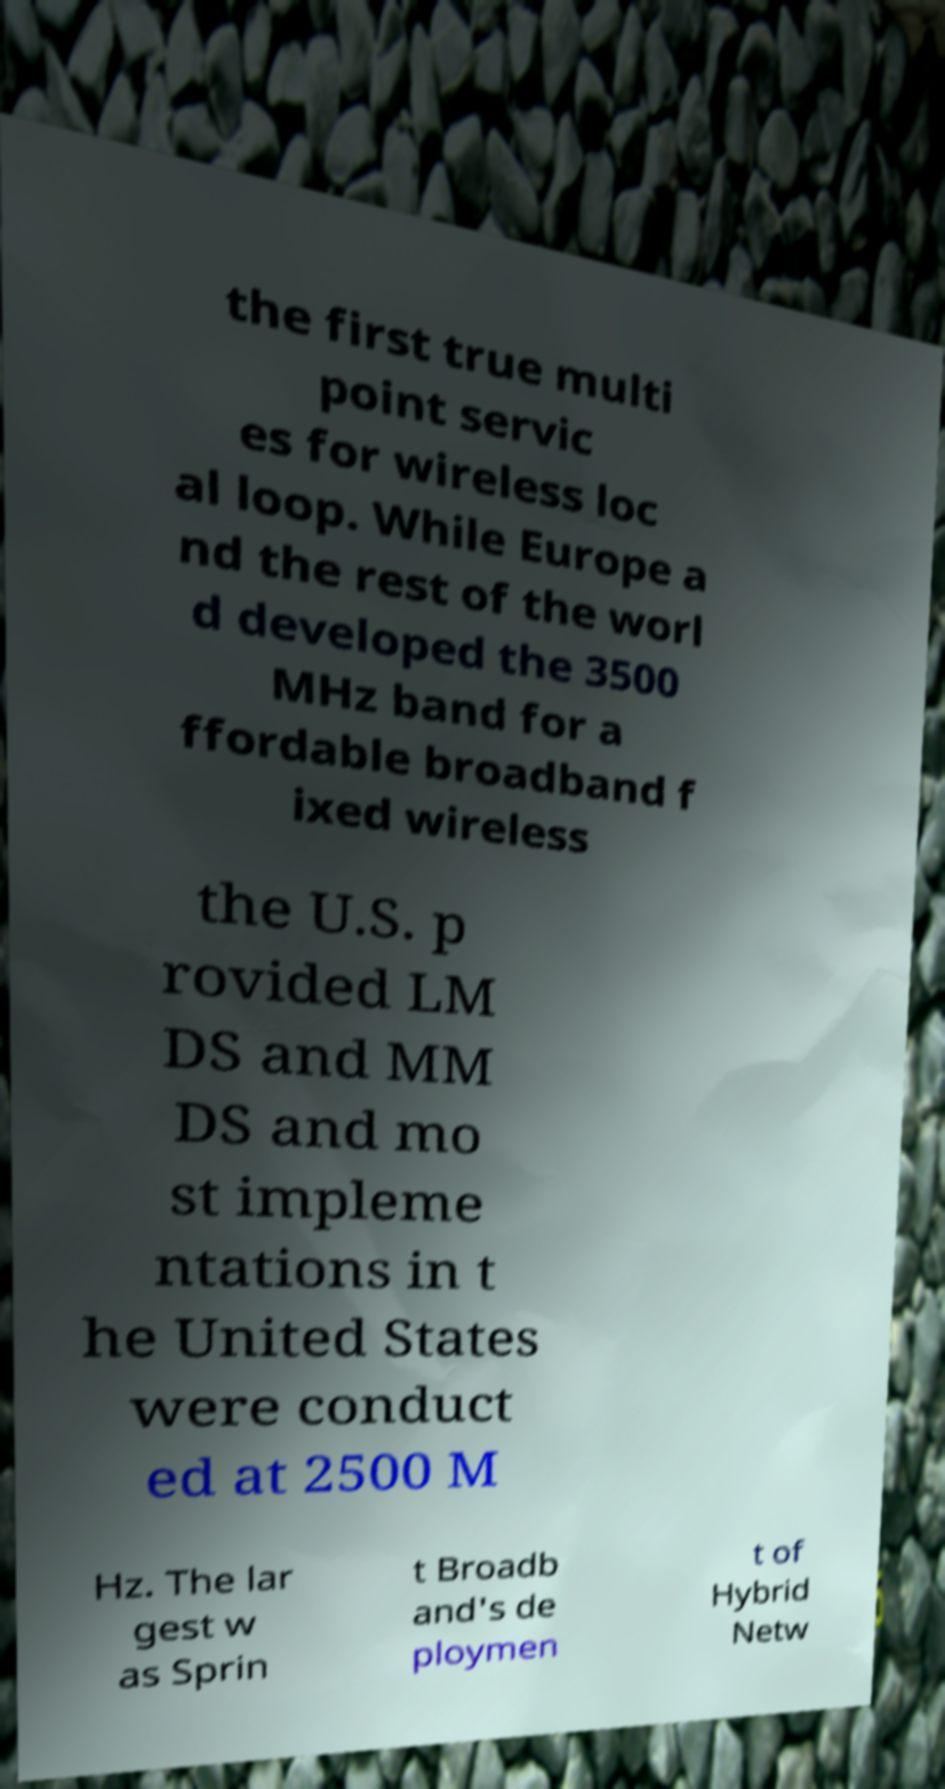Can you accurately transcribe the text from the provided image for me? the first true multi point servic es for wireless loc al loop. While Europe a nd the rest of the worl d developed the 3500 MHz band for a ffordable broadband f ixed wireless the U.S. p rovided LM DS and MM DS and mo st impleme ntations in t he United States were conduct ed at 2500 M Hz. The lar gest w as Sprin t Broadb and's de ploymen t of Hybrid Netw 